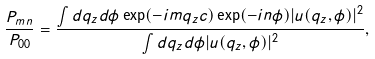Convert formula to latex. <formula><loc_0><loc_0><loc_500><loc_500>\frac { P _ { m n } } { P _ { 0 0 } } = \frac { \int d q _ { z } d \phi \exp ( - i m q _ { z } c ) \exp ( - i n \phi ) | u ( q _ { z } , \phi ) | ^ { 2 } } { \int d q _ { z } d \phi | u ( q _ { z } , \phi ) | ^ { 2 } } ,</formula> 